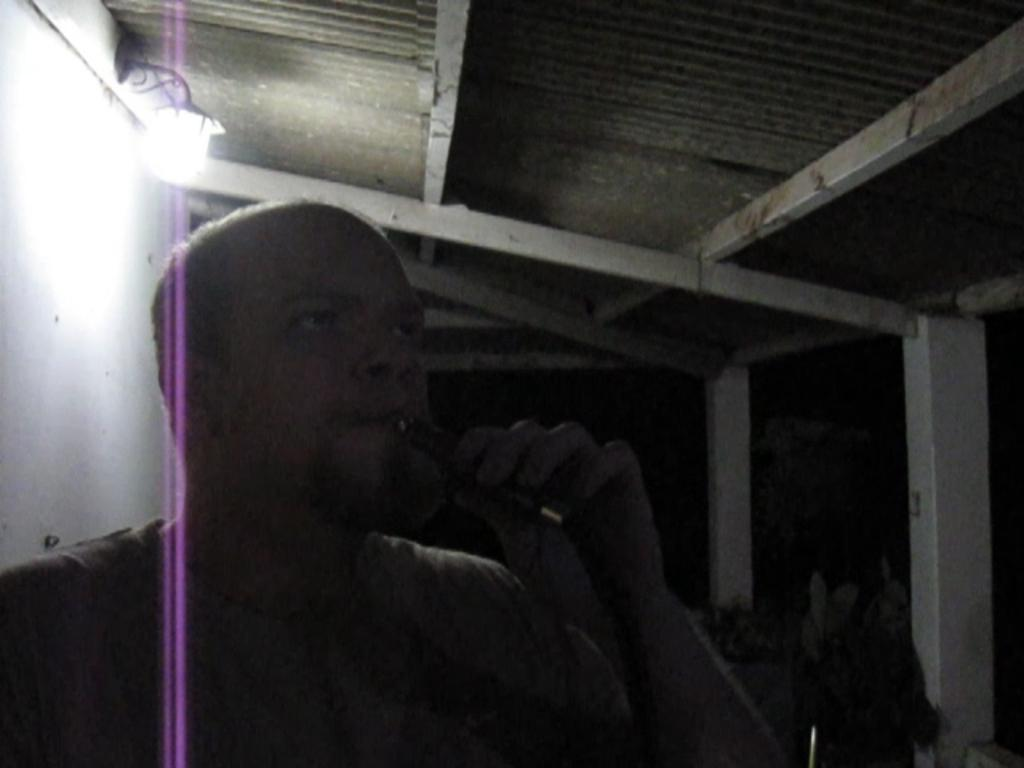What is present in the image? There is a person in the image. What is the person holding? The person is holding an object. What can be seen in the background of the image? There is light, a shed, and poles in the background of the image. What type of wound can be seen on the person's arm in the image? There is no wound visible on the person's arm in the image. What type of flag is flying on the pole in the image? There is no flag present in the image; only poles are visible in the background. 